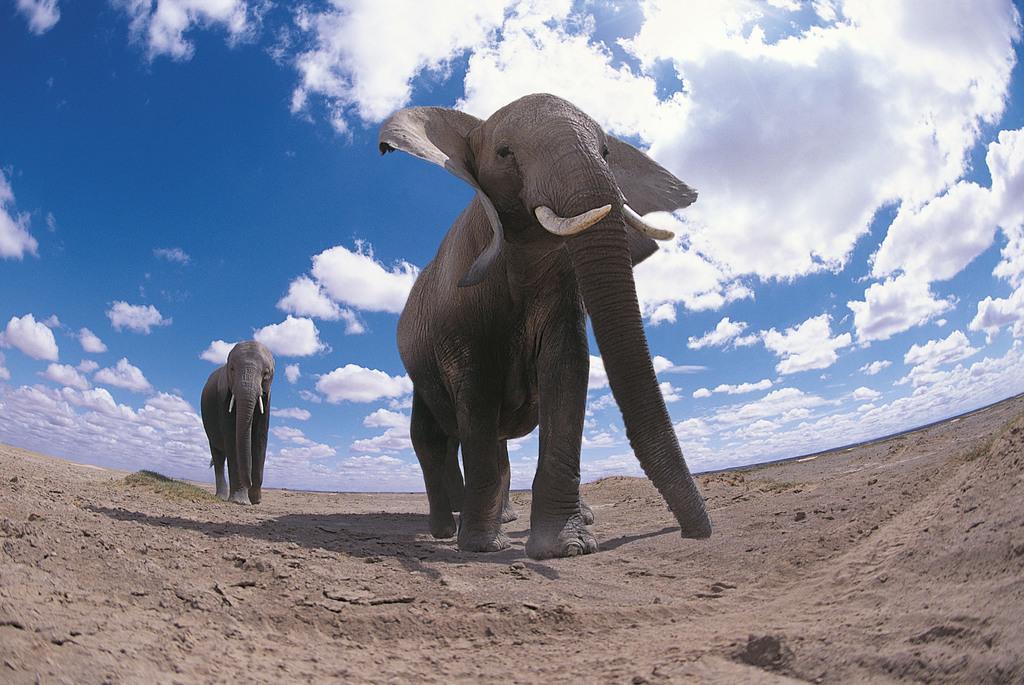Please provide a concise description of this image. In this image there are two elephants visible on the land, at the top there is the sky ,clouds visible. 